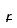<formula> <loc_0><loc_0><loc_500><loc_500>\overline { r }</formula> 